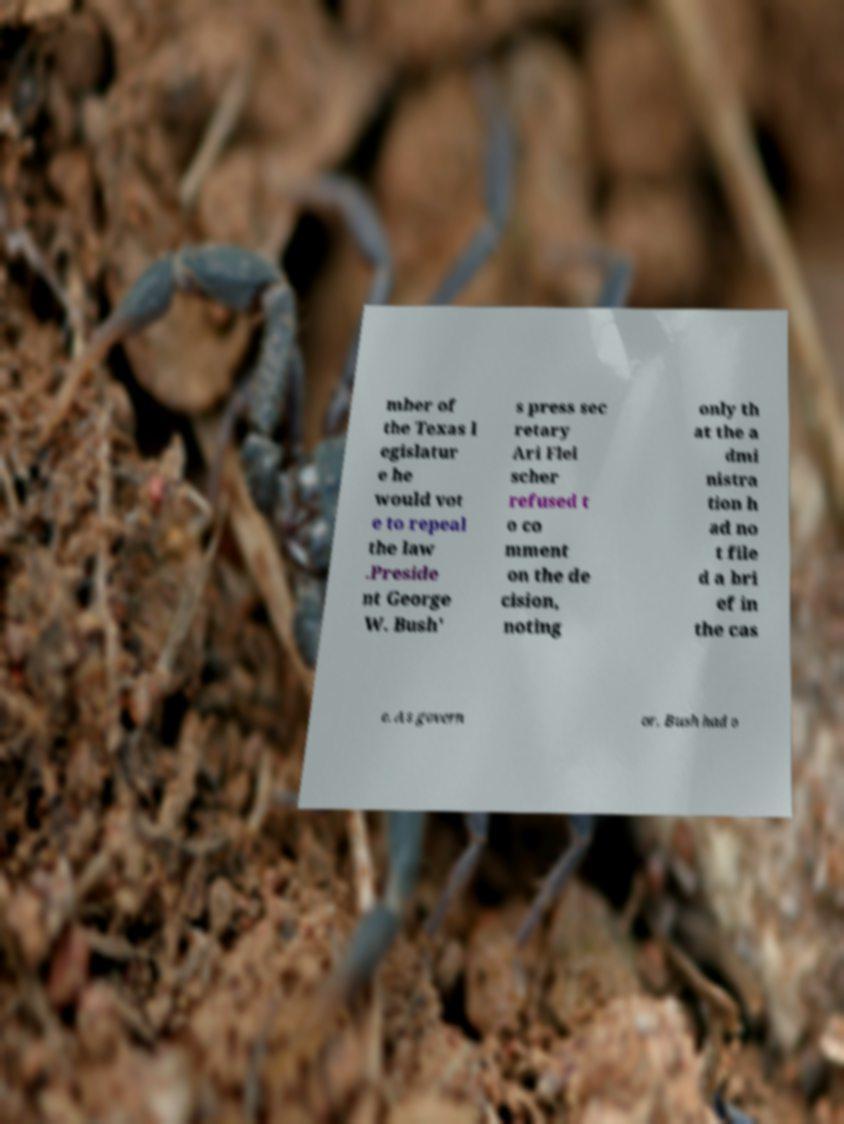Could you assist in decoding the text presented in this image and type it out clearly? mber of the Texas l egislatur e he would vot e to repeal the law .Preside nt George W. Bush' s press sec retary Ari Flei scher refused t o co mment on the de cision, noting only th at the a dmi nistra tion h ad no t file d a bri ef in the cas e. As govern or, Bush had o 